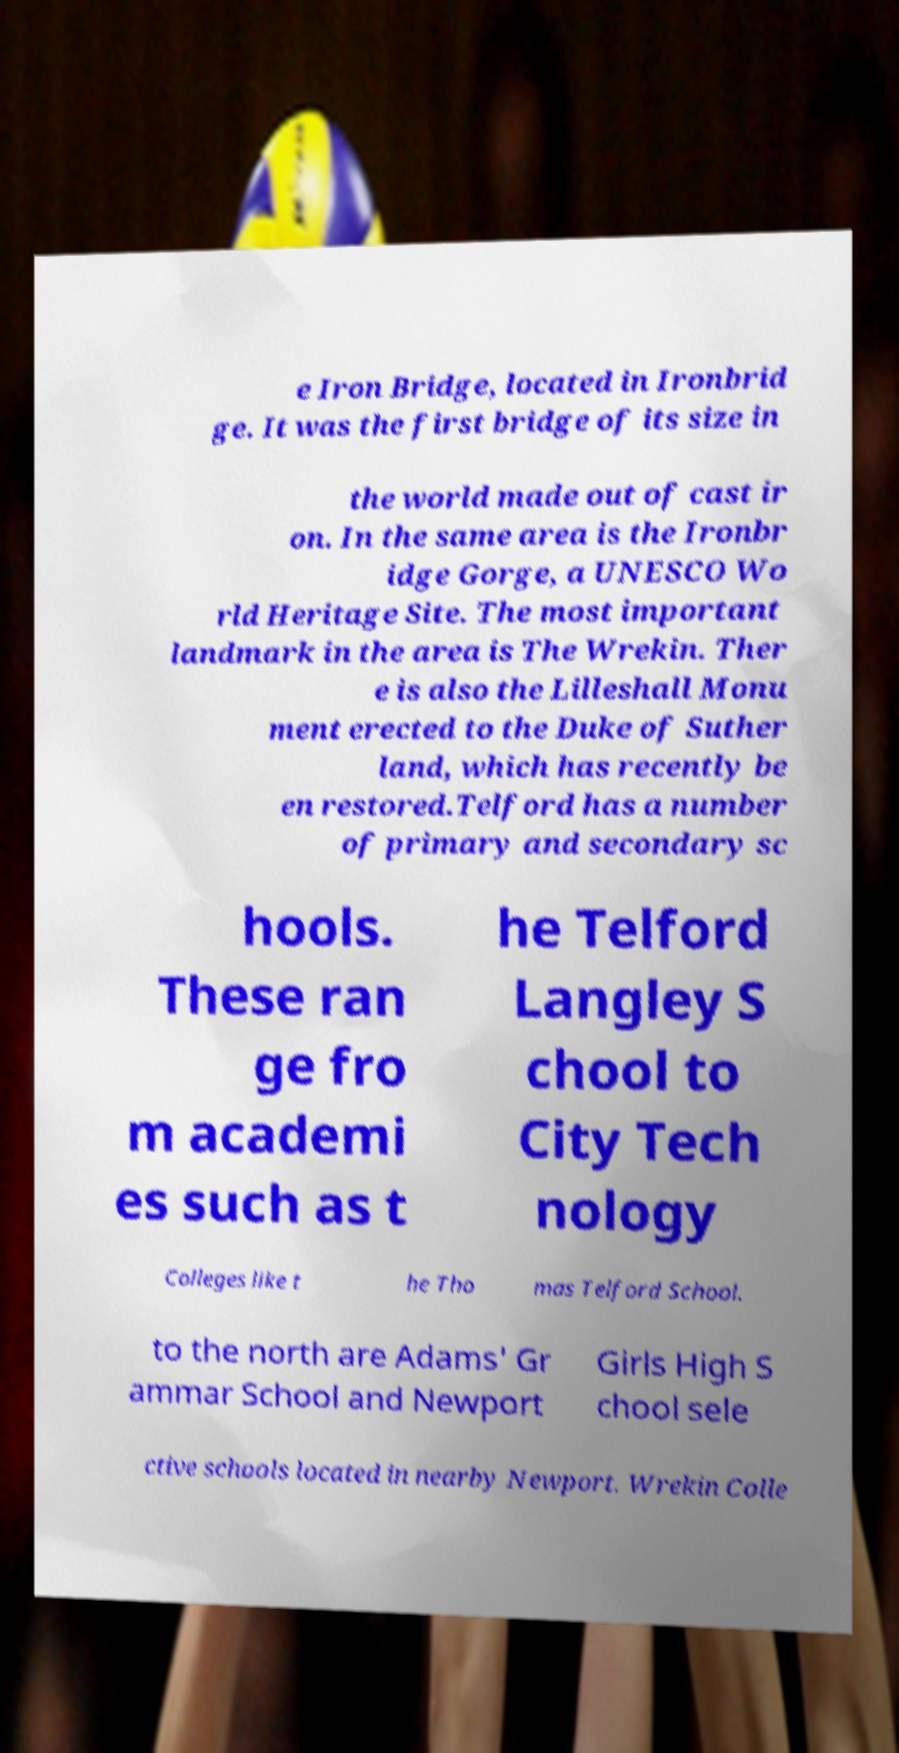For documentation purposes, I need the text within this image transcribed. Could you provide that? e Iron Bridge, located in Ironbrid ge. It was the first bridge of its size in the world made out of cast ir on. In the same area is the Ironbr idge Gorge, a UNESCO Wo rld Heritage Site. The most important landmark in the area is The Wrekin. Ther e is also the Lilleshall Monu ment erected to the Duke of Suther land, which has recently be en restored.Telford has a number of primary and secondary sc hools. These ran ge fro m academi es such as t he Telford Langley S chool to City Tech nology Colleges like t he Tho mas Telford School. to the north are Adams' Gr ammar School and Newport Girls High S chool sele ctive schools located in nearby Newport. Wrekin Colle 